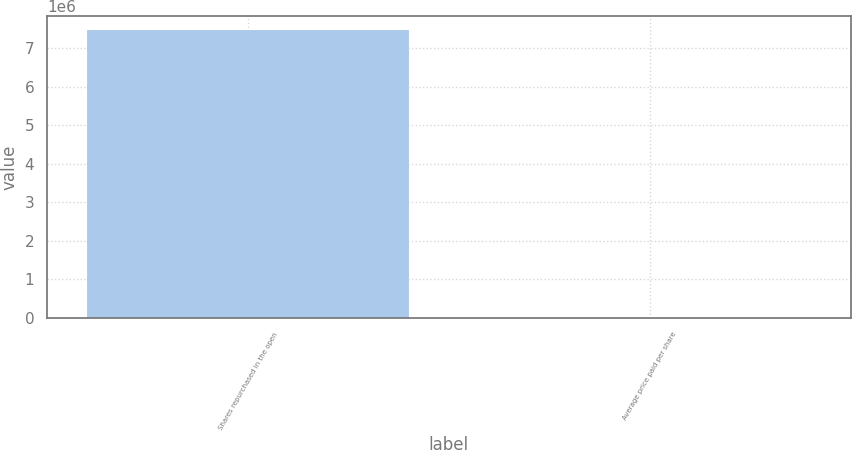<chart> <loc_0><loc_0><loc_500><loc_500><bar_chart><fcel>Shares repurchased in the open<fcel>Average price paid per share<nl><fcel>7.46723e+06<fcel>80.5<nl></chart> 